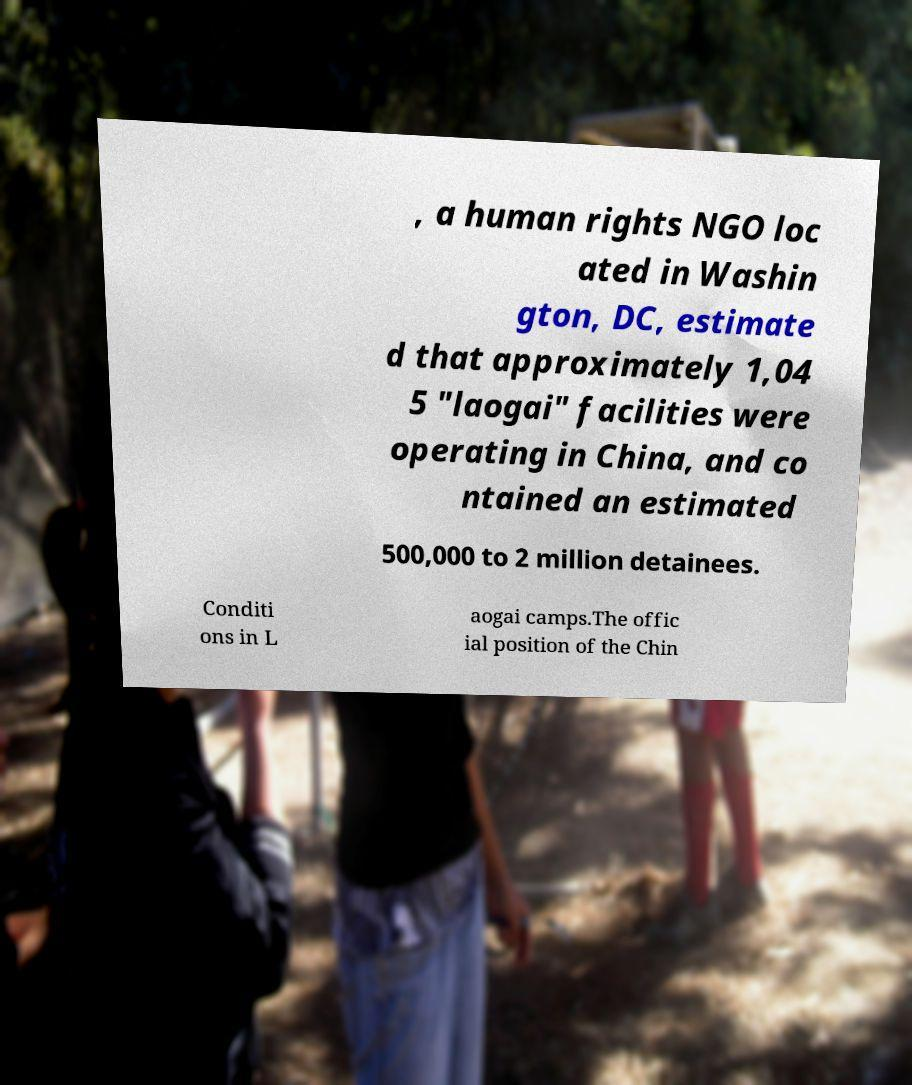Could you assist in decoding the text presented in this image and type it out clearly? , a human rights NGO loc ated in Washin gton, DC, estimate d that approximately 1,04 5 "laogai" facilities were operating in China, and co ntained an estimated 500,000 to 2 million detainees. Conditi ons in L aogai camps.The offic ial position of the Chin 